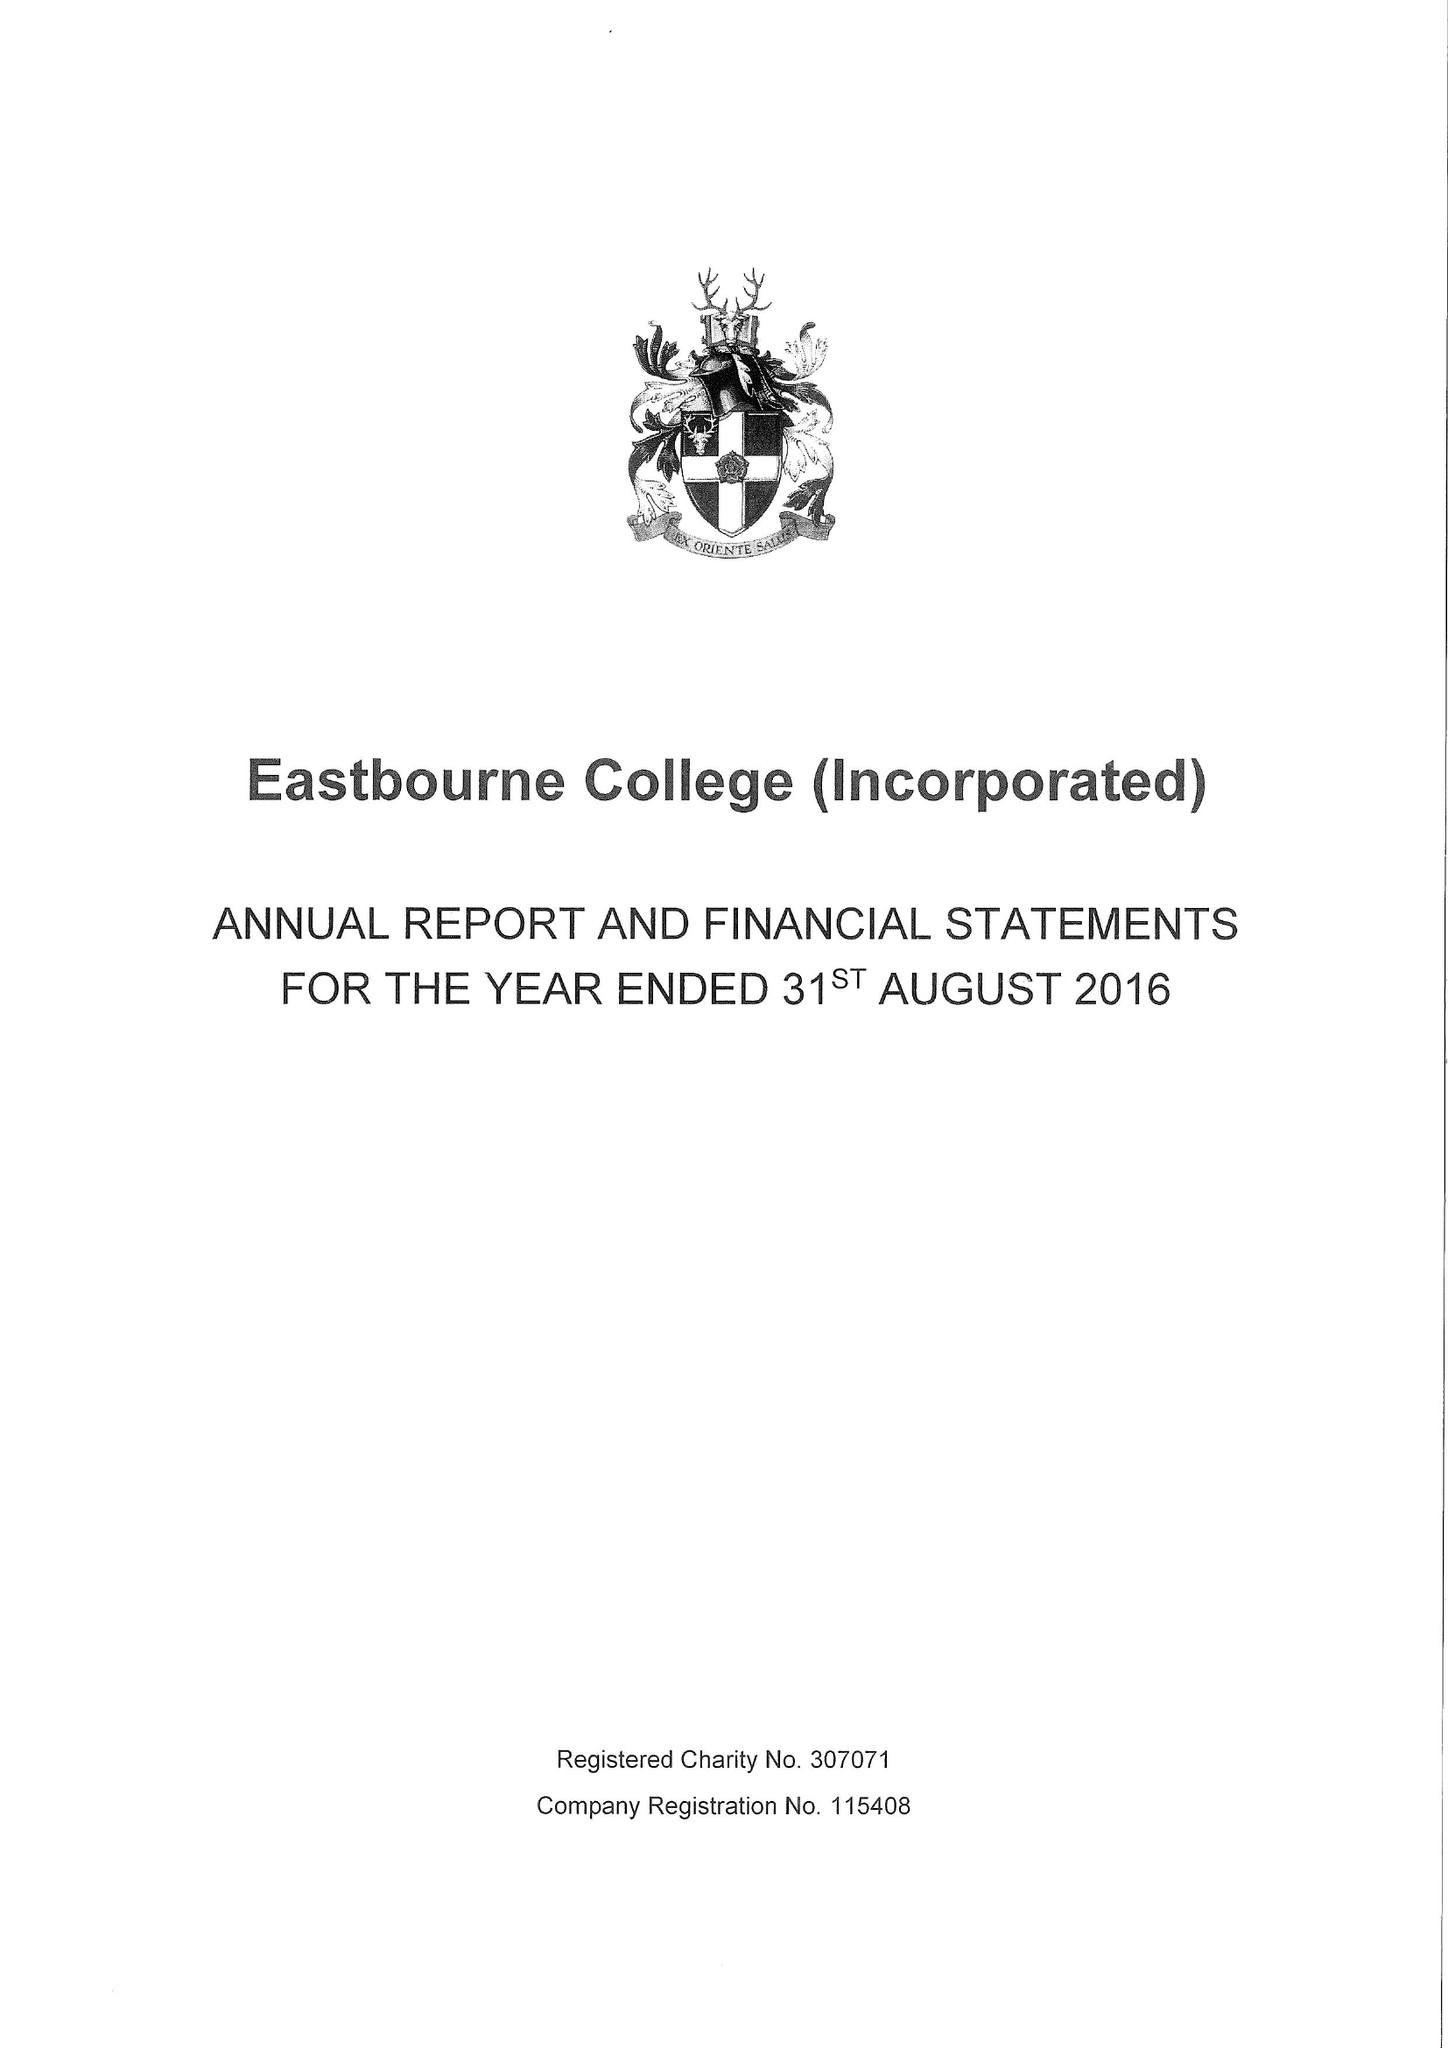What is the value for the income_annually_in_british_pounds?
Answer the question using a single word or phrase. 23010000.00 